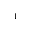<formula> <loc_0><loc_0><loc_500><loc_500>_ { 1 }</formula> 